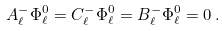Convert formula to latex. <formula><loc_0><loc_0><loc_500><loc_500>A ^ { - } _ { \ell } \Phi ^ { 0 } _ { \ell } = C ^ { - } _ { \ell } \Phi ^ { 0 } _ { \ell } = B ^ { - } _ { \ell } \Phi ^ { 0 } _ { \ell } = 0 \, .</formula> 